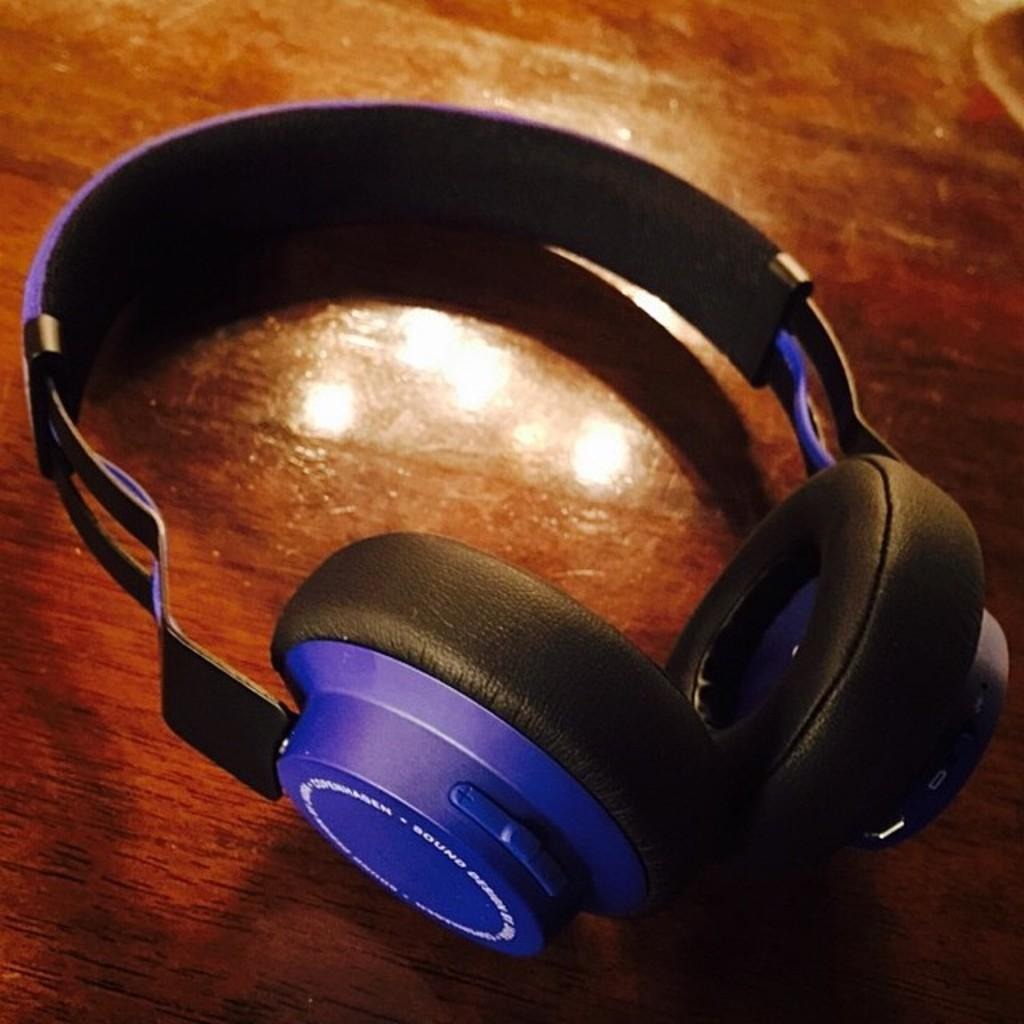What is the main object in the image? There is an headset in the image. Where is the headset located? The headset is placed on a wooden plank. What type of soup is being served in the headset in the image? There is no soup present in the image; it features an headset placed on a wooden plank. Can you tell me how many pieces of popcorn are in the headset? There is no popcorn present in the image; it features an headset placed on a wooden plank. 